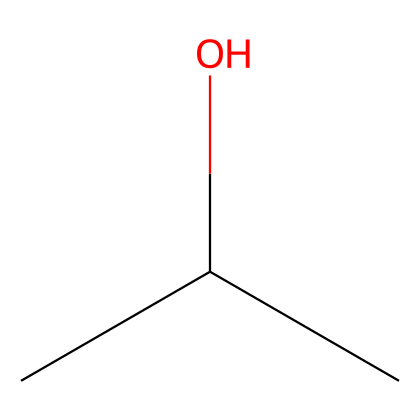What is the name of the chemical represented by this SMILES? The SMILES CC(C)O corresponds to isopropyl alcohol, which is a common name for the compound with the structure shown.
Answer: isopropyl alcohol How many carbon atoms are present in isopropyl alcohol? In the SMILES CC(C)O, there are three carbon atoms (C) present. The two C's in the beginning represent a branched structure, and the third C is attached to the hydroxyl group.
Answer: three What functional group is present in isopropyl alcohol? The structural representation indicates a hydroxyl group (-OH) attached to one of the carbon atoms in the chain, which characterizes it as an alcohol.
Answer: hydroxyl group Is isopropyl alcohol a primary, secondary, or tertiary alcohol? The carbon that is directly bonded to the hydroxyl group is attached to two other carbon atoms, indicating that isopropyl alcohol is categorized as a secondary alcohol.
Answer: secondary How many hydrogen atoms are attached to the isopropyl alcohol? In total, there are eight hydrogen atoms associated with the three carbon atoms and one hydroxyl group in the structure represented by CC(C)O.
Answer: eight What type of hydrocarbon is isopropyl alcohol considered? The chemical structure indicates that isopropyl alcohol contains both carbon and oxygen atoms and is categorized as an alcohol within the hydrocarbon family. Although it includes oxygen, it is derived from hydrocarbons, hence classified as an aliphatic alcohol.
Answer: aliphatic alcohol 